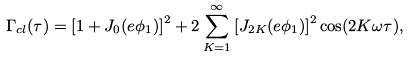Convert formula to latex. <formula><loc_0><loc_0><loc_500><loc_500>\Gamma _ { c l } ( \tau ) = \left [ 1 + J _ { 0 } ( e \phi _ { 1 } ) \right ] ^ { 2 } + 2 \sum _ { K = 1 } ^ { \infty } \left [ J _ { 2 K } ( e \phi _ { 1 } ) \right ] ^ { 2 } \cos ( 2 K \omega \tau ) ,</formula> 